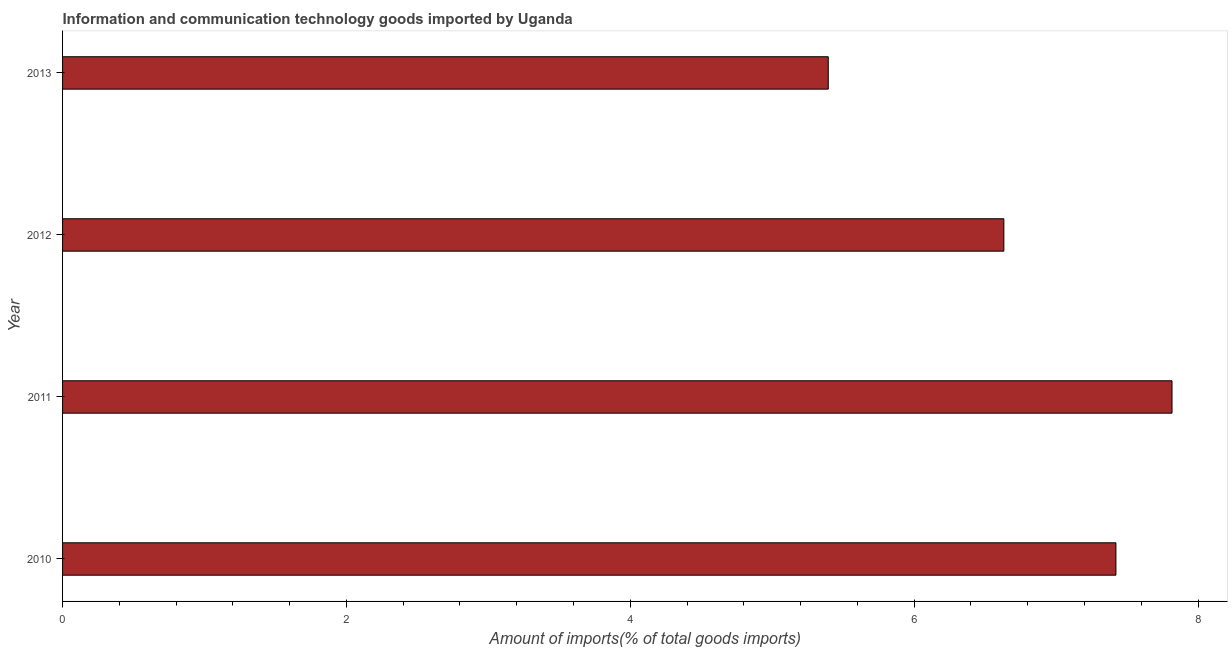Does the graph contain any zero values?
Provide a succinct answer. No. What is the title of the graph?
Offer a very short reply. Information and communication technology goods imported by Uganda. What is the label or title of the X-axis?
Provide a short and direct response. Amount of imports(% of total goods imports). What is the label or title of the Y-axis?
Make the answer very short. Year. What is the amount of ict goods imports in 2011?
Provide a short and direct response. 7.82. Across all years, what is the maximum amount of ict goods imports?
Your answer should be compact. 7.82. Across all years, what is the minimum amount of ict goods imports?
Provide a succinct answer. 5.39. In which year was the amount of ict goods imports maximum?
Provide a short and direct response. 2011. What is the sum of the amount of ict goods imports?
Your response must be concise. 27.26. What is the difference between the amount of ict goods imports in 2012 and 2013?
Provide a succinct answer. 1.24. What is the average amount of ict goods imports per year?
Provide a succinct answer. 6.82. What is the median amount of ict goods imports?
Your answer should be compact. 7.03. In how many years, is the amount of ict goods imports greater than 6.8 %?
Your answer should be compact. 2. Do a majority of the years between 2011 and 2013 (inclusive) have amount of ict goods imports greater than 5.2 %?
Offer a terse response. Yes. What is the ratio of the amount of ict goods imports in 2011 to that in 2012?
Your answer should be very brief. 1.18. Is the amount of ict goods imports in 2011 less than that in 2012?
Provide a succinct answer. No. Is the difference between the amount of ict goods imports in 2010 and 2012 greater than the difference between any two years?
Make the answer very short. No. What is the difference between the highest and the second highest amount of ict goods imports?
Make the answer very short. 0.4. What is the difference between the highest and the lowest amount of ict goods imports?
Ensure brevity in your answer.  2.42. In how many years, is the amount of ict goods imports greater than the average amount of ict goods imports taken over all years?
Your answer should be compact. 2. How many bars are there?
Ensure brevity in your answer.  4. Are the values on the major ticks of X-axis written in scientific E-notation?
Provide a succinct answer. No. What is the Amount of imports(% of total goods imports) of 2010?
Keep it short and to the point. 7.42. What is the Amount of imports(% of total goods imports) of 2011?
Provide a succinct answer. 7.82. What is the Amount of imports(% of total goods imports) of 2012?
Provide a short and direct response. 6.63. What is the Amount of imports(% of total goods imports) in 2013?
Provide a short and direct response. 5.39. What is the difference between the Amount of imports(% of total goods imports) in 2010 and 2011?
Your response must be concise. -0.4. What is the difference between the Amount of imports(% of total goods imports) in 2010 and 2012?
Your response must be concise. 0.79. What is the difference between the Amount of imports(% of total goods imports) in 2010 and 2013?
Offer a terse response. 2.03. What is the difference between the Amount of imports(% of total goods imports) in 2011 and 2012?
Offer a terse response. 1.18. What is the difference between the Amount of imports(% of total goods imports) in 2011 and 2013?
Your answer should be compact. 2.42. What is the difference between the Amount of imports(% of total goods imports) in 2012 and 2013?
Make the answer very short. 1.24. What is the ratio of the Amount of imports(% of total goods imports) in 2010 to that in 2011?
Provide a short and direct response. 0.95. What is the ratio of the Amount of imports(% of total goods imports) in 2010 to that in 2012?
Make the answer very short. 1.12. What is the ratio of the Amount of imports(% of total goods imports) in 2010 to that in 2013?
Offer a very short reply. 1.38. What is the ratio of the Amount of imports(% of total goods imports) in 2011 to that in 2012?
Provide a succinct answer. 1.18. What is the ratio of the Amount of imports(% of total goods imports) in 2011 to that in 2013?
Offer a terse response. 1.45. What is the ratio of the Amount of imports(% of total goods imports) in 2012 to that in 2013?
Give a very brief answer. 1.23. 